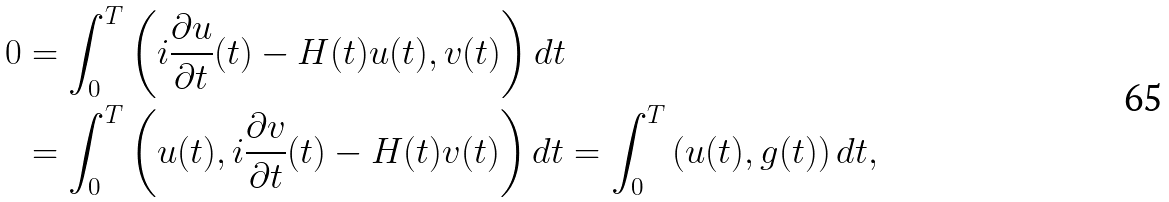<formula> <loc_0><loc_0><loc_500><loc_500>0 & = \int _ { 0 } ^ { T } \left ( i \frac { \partial u } { \partial t } ( t ) - H ( t ) u ( t ) , v ( t ) \right ) d t \\ & = \int _ { 0 } ^ { T } \left ( u ( t ) , i \frac { \partial v } { \partial t } ( t ) - H ( t ) v ( t ) \right ) d t = \int _ { 0 } ^ { T } \left ( u ( t ) , g ( t ) \right ) d t ,</formula> 